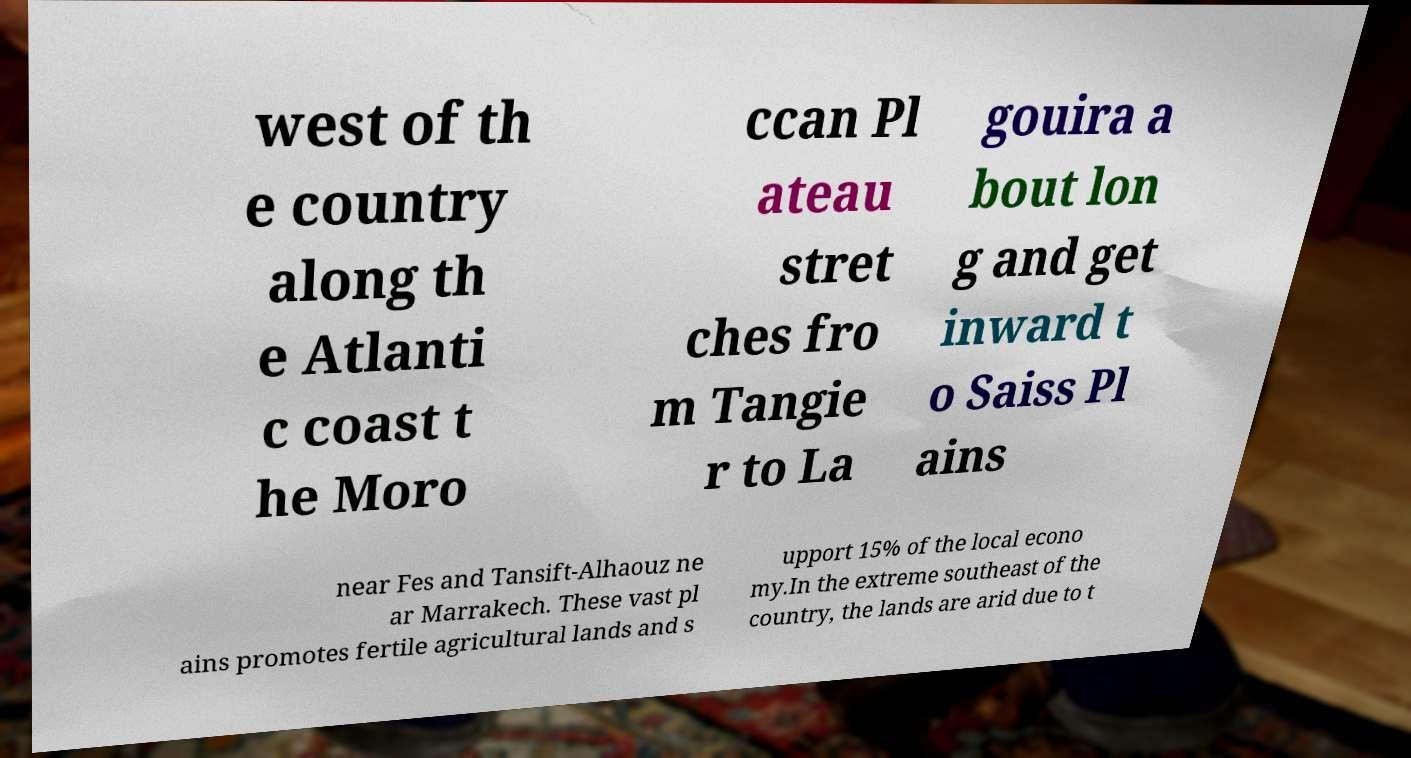There's text embedded in this image that I need extracted. Can you transcribe it verbatim? west of th e country along th e Atlanti c coast t he Moro ccan Pl ateau stret ches fro m Tangie r to La gouira a bout lon g and get inward t o Saiss Pl ains near Fes and Tansift-Alhaouz ne ar Marrakech. These vast pl ains promotes fertile agricultural lands and s upport 15% of the local econo my.In the extreme southeast of the country, the lands are arid due to t 